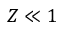Convert formula to latex. <formula><loc_0><loc_0><loc_500><loc_500>Z \ll 1</formula> 